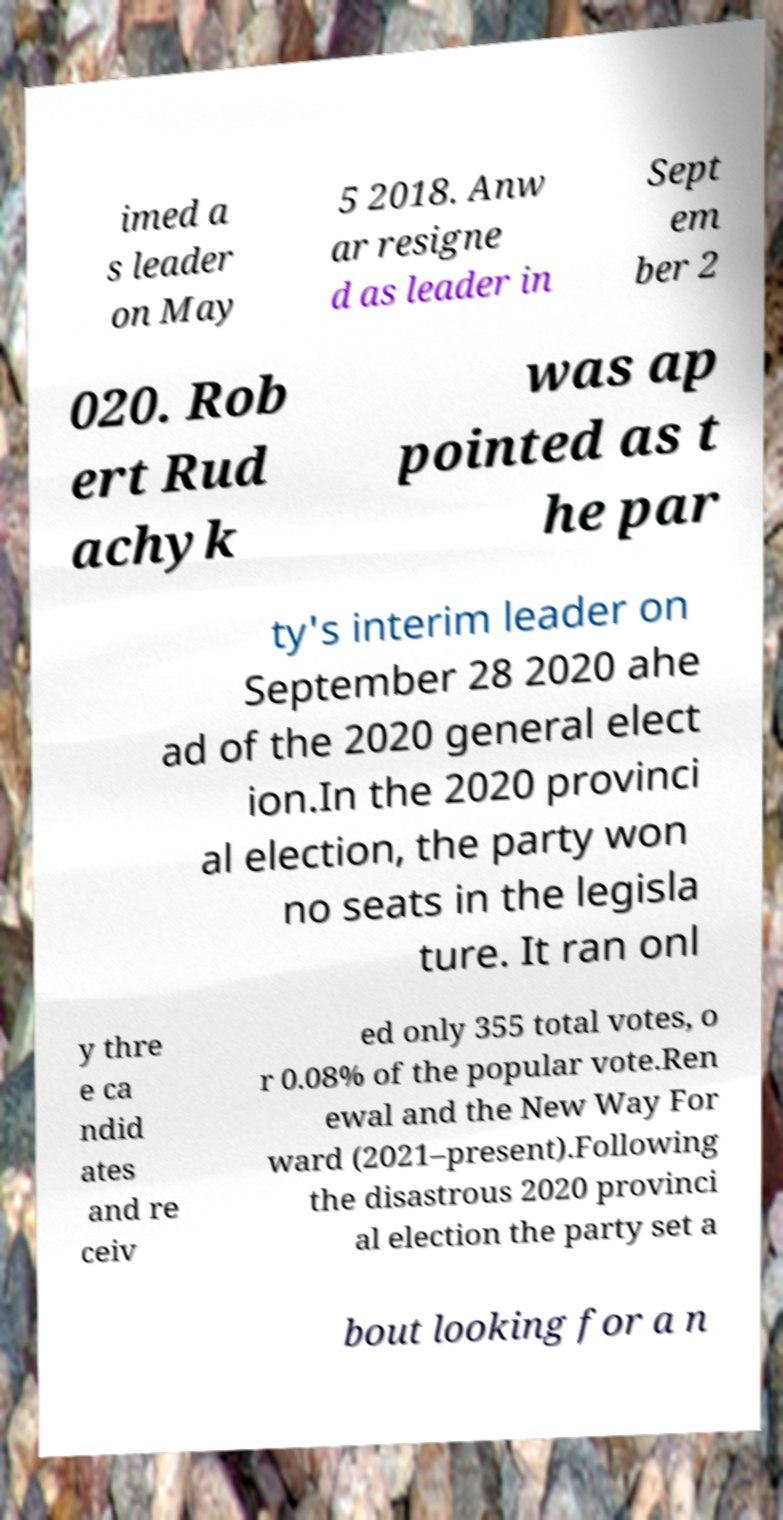Could you assist in decoding the text presented in this image and type it out clearly? imed a s leader on May 5 2018. Anw ar resigne d as leader in Sept em ber 2 020. Rob ert Rud achyk was ap pointed as t he par ty's interim leader on September 28 2020 ahe ad of the 2020 general elect ion.In the 2020 provinci al election, the party won no seats in the legisla ture. It ran onl y thre e ca ndid ates and re ceiv ed only 355 total votes, o r 0.08% of the popular vote.Ren ewal and the New Way For ward (2021–present).Following the disastrous 2020 provinci al election the party set a bout looking for a n 